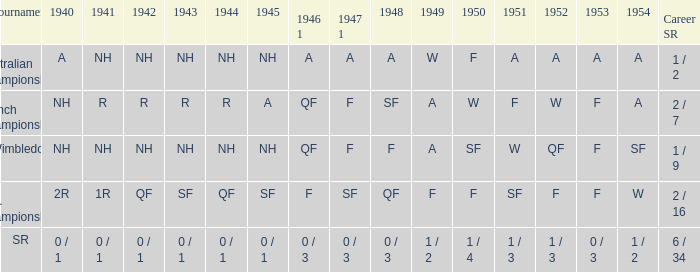What is the competition that had an outcome of a in 1954 and nh in 1942? Australian Championships. 